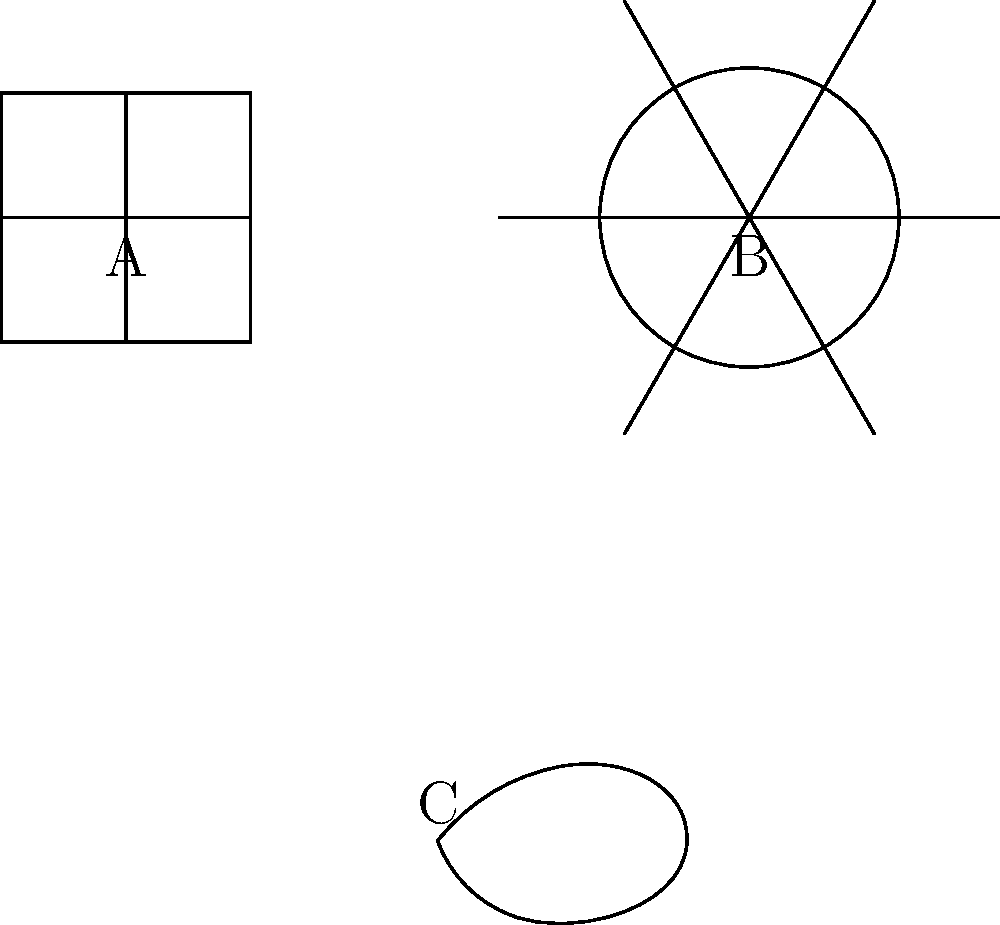Which of the artistic motifs shown above (A, B, or C) is most likely influenced by Islamic geometric patterns? To answer this question, we need to analyze the characteristics of each motif and compare them with known features of Islamic geometric patterns:

1. Motif A: This pattern consists of interlocking right angles forming a repeating square shape. This is characteristic of the Greek key or meander pattern, commonly found in ancient Greek and Roman art.

2. Motif B: This pattern shows a six-pointed star-like shape with intersecting lines and arcs. It demonstrates rotational symmetry and interlacing geometric forms, which are hallmarks of Islamic geometric patterns. These patterns often feature complex star shapes and repeated geometric elements.

3. Motif C: This pattern resembles a stylized cloud or wave form. This type of curvilinear, flowing design is typical of traditional Chinese art, particularly in cloud motifs found in textiles and ceramics.

Among these three motifs, B most closely aligns with the characteristics of Islamic geometric patterns due to its use of symmetry, interlacing lines, and star-like formations.
Answer: B 